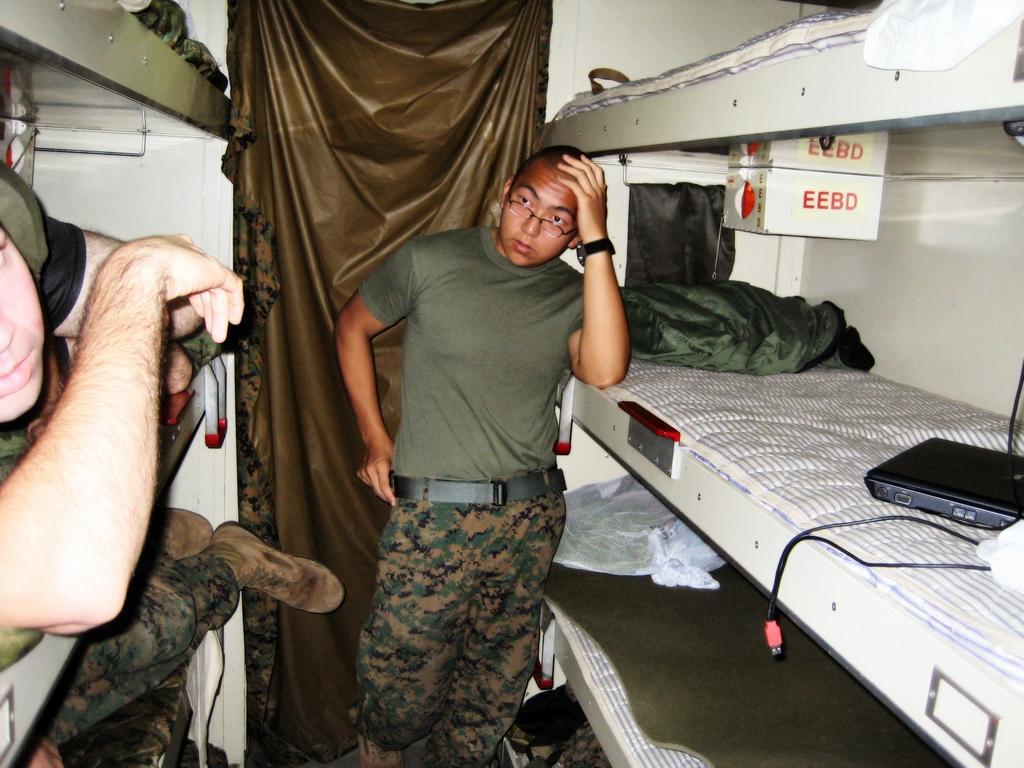Can you describe this image briefly? The image is taken in the compartment. In the center of the image there is a man standing next to him there are people sleeping in the compartments. In the background there is a cloth. 